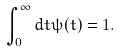<formula> <loc_0><loc_0><loc_500><loc_500>\int _ { 0 } ^ { \infty } d t \psi ( t ) = 1 .</formula> 